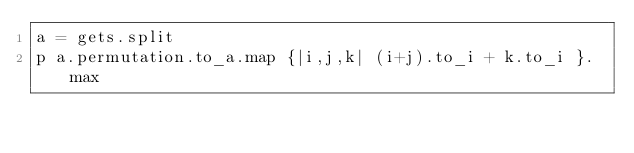Convert code to text. <code><loc_0><loc_0><loc_500><loc_500><_Ruby_>a = gets.split
p a.permutation.to_a.map {|i,j,k| (i+j).to_i + k.to_i }.max</code> 